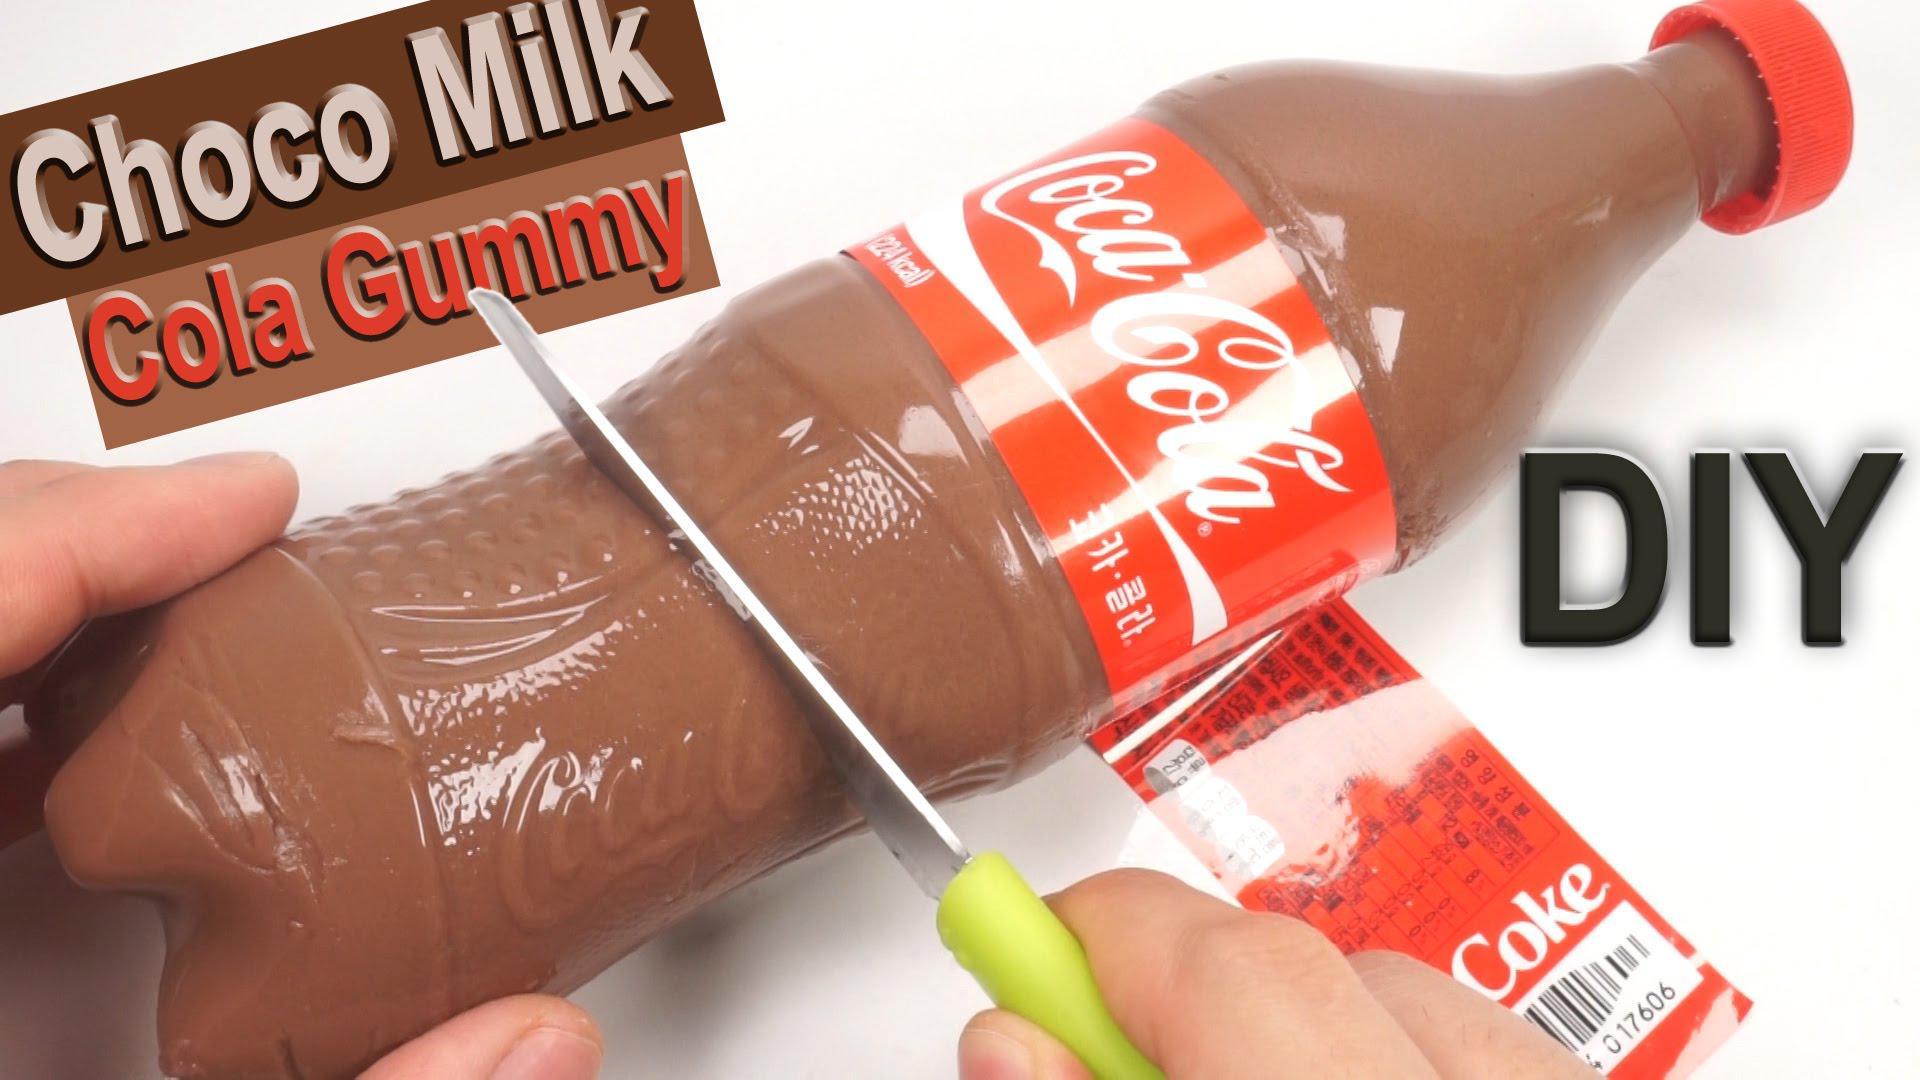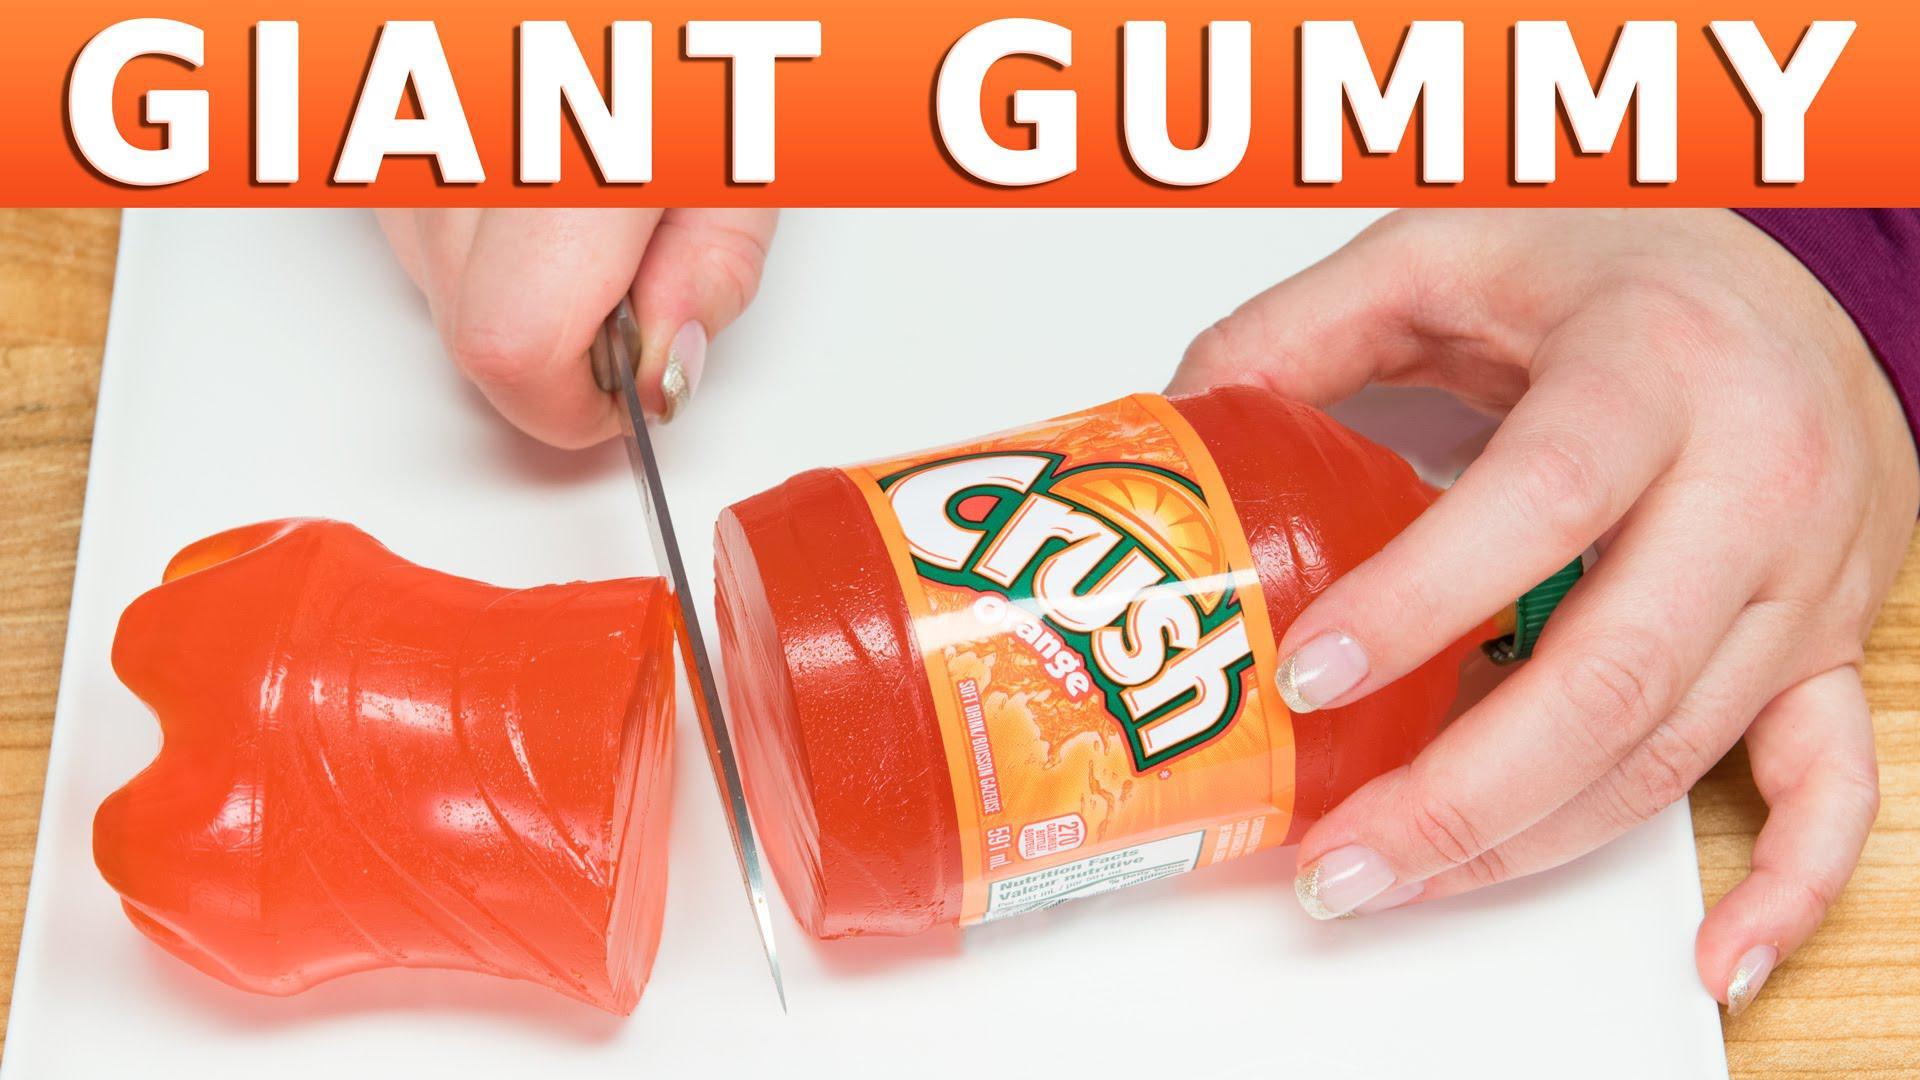The first image is the image on the left, the second image is the image on the right. Given the left and right images, does the statement "One of the gummy sodas is orange." hold true? Answer yes or no. Yes. The first image is the image on the left, the second image is the image on the right. For the images shown, is this caption "One image includes a silver-bladed knife and a bottle shape that is cut in two separated parts, and a hand is grasping a bottle that is not split in two parts in the other image." true? Answer yes or no. Yes. 